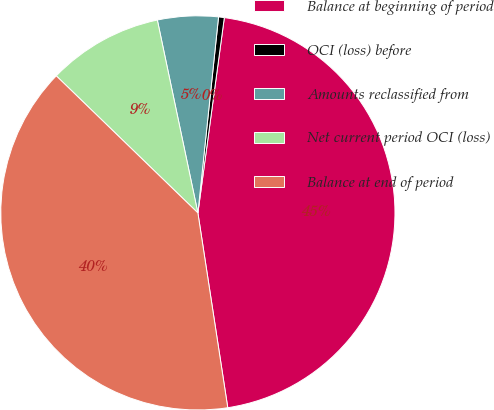<chart> <loc_0><loc_0><loc_500><loc_500><pie_chart><fcel>Balance at beginning of period<fcel>OCI (loss) before<fcel>Amounts reclassified from<fcel>Net current period OCI (loss)<fcel>Balance at end of period<nl><fcel>45.43%<fcel>0.47%<fcel>4.97%<fcel>9.46%<fcel>39.66%<nl></chart> 